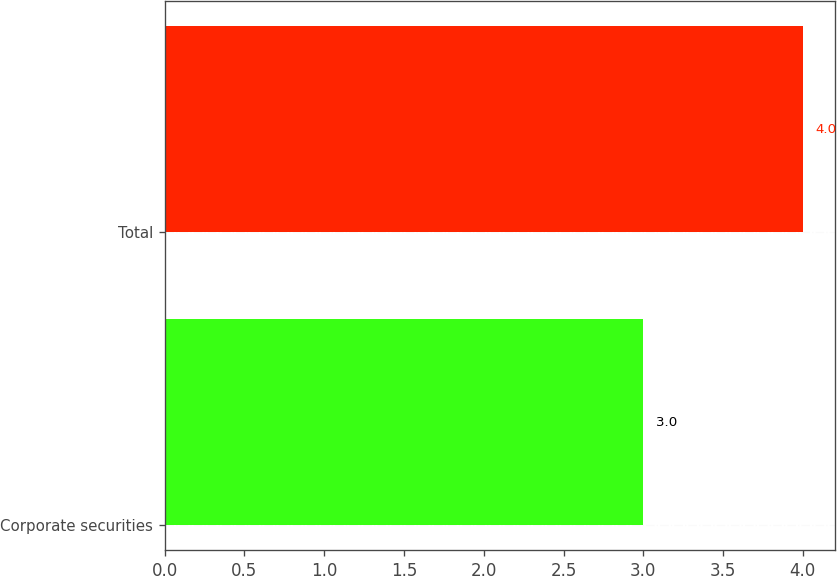Convert chart to OTSL. <chart><loc_0><loc_0><loc_500><loc_500><bar_chart><fcel>Corporate securities<fcel>Total<nl><fcel>3<fcel>4<nl></chart> 